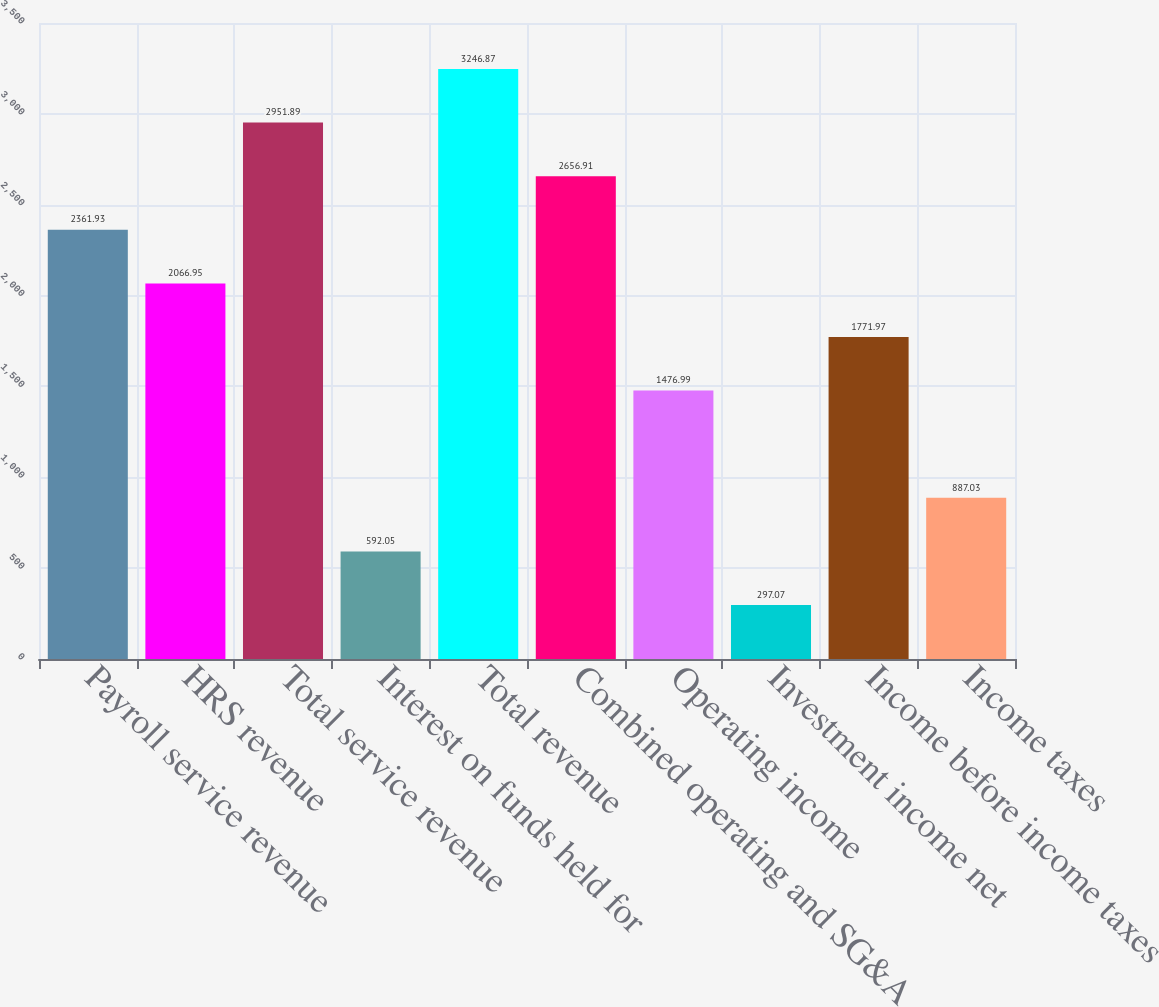Convert chart. <chart><loc_0><loc_0><loc_500><loc_500><bar_chart><fcel>Payroll service revenue<fcel>HRS revenue<fcel>Total service revenue<fcel>Interest on funds held for<fcel>Total revenue<fcel>Combined operating and SG&A<fcel>Operating income<fcel>Investment income net<fcel>Income before income taxes<fcel>Income taxes<nl><fcel>2361.93<fcel>2066.95<fcel>2951.89<fcel>592.05<fcel>3246.87<fcel>2656.91<fcel>1476.99<fcel>297.07<fcel>1771.97<fcel>887.03<nl></chart> 